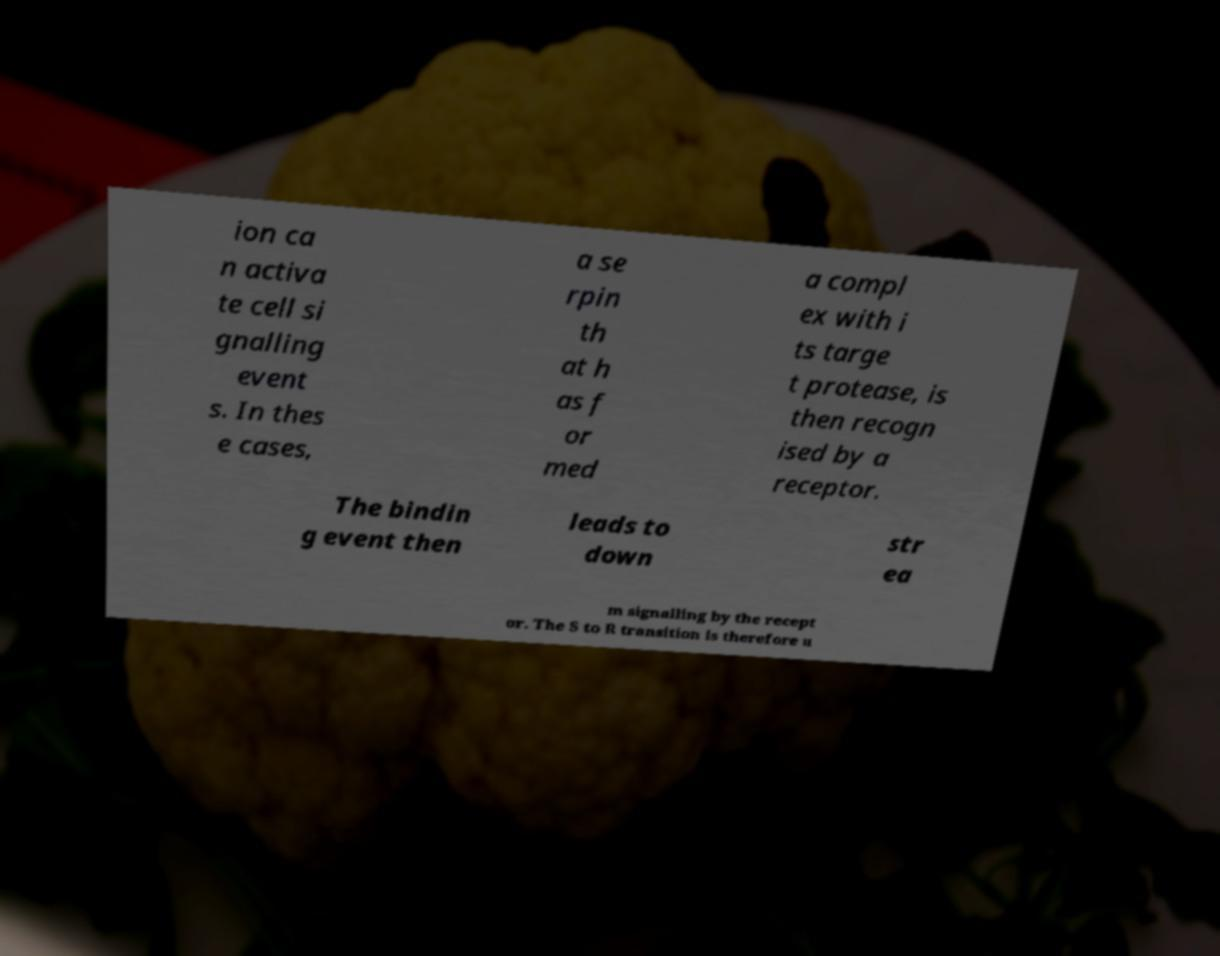Can you read and provide the text displayed in the image?This photo seems to have some interesting text. Can you extract and type it out for me? ion ca n activa te cell si gnalling event s. In thes e cases, a se rpin th at h as f or med a compl ex with i ts targe t protease, is then recogn ised by a receptor. The bindin g event then leads to down str ea m signalling by the recept or. The S to R transition is therefore u 